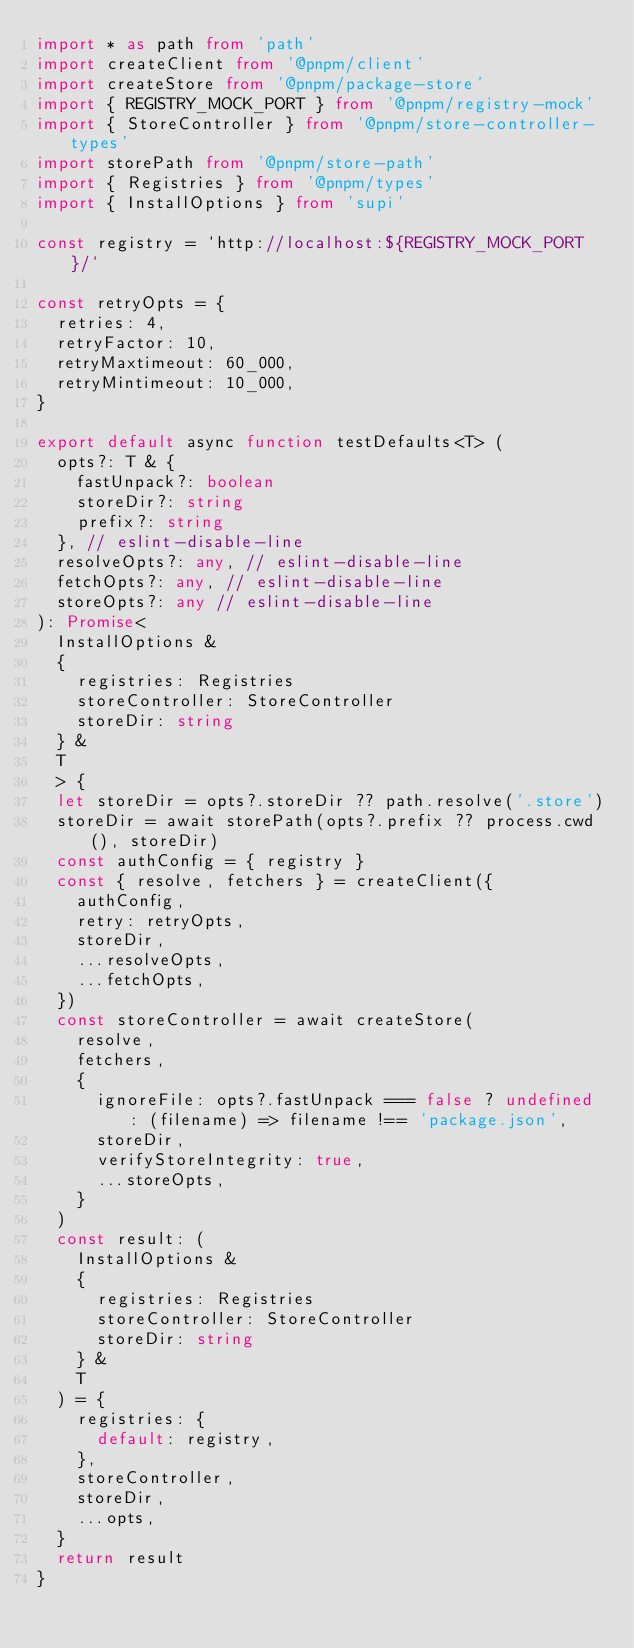<code> <loc_0><loc_0><loc_500><loc_500><_TypeScript_>import * as path from 'path'
import createClient from '@pnpm/client'
import createStore from '@pnpm/package-store'
import { REGISTRY_MOCK_PORT } from '@pnpm/registry-mock'
import { StoreController } from '@pnpm/store-controller-types'
import storePath from '@pnpm/store-path'
import { Registries } from '@pnpm/types'
import { InstallOptions } from 'supi'

const registry = `http://localhost:${REGISTRY_MOCK_PORT}/`

const retryOpts = {
  retries: 4,
  retryFactor: 10,
  retryMaxtimeout: 60_000,
  retryMintimeout: 10_000,
}

export default async function testDefaults<T> (
  opts?: T & {
    fastUnpack?: boolean
    storeDir?: string
    prefix?: string
  }, // eslint-disable-line
  resolveOpts?: any, // eslint-disable-line
  fetchOpts?: any, // eslint-disable-line
  storeOpts?: any // eslint-disable-line
): Promise<
  InstallOptions &
  {
    registries: Registries
    storeController: StoreController
    storeDir: string
  } &
  T
  > {
  let storeDir = opts?.storeDir ?? path.resolve('.store')
  storeDir = await storePath(opts?.prefix ?? process.cwd(), storeDir)
  const authConfig = { registry }
  const { resolve, fetchers } = createClient({
    authConfig,
    retry: retryOpts,
    storeDir,
    ...resolveOpts,
    ...fetchOpts,
  })
  const storeController = await createStore(
    resolve,
    fetchers,
    {
      ignoreFile: opts?.fastUnpack === false ? undefined : (filename) => filename !== 'package.json',
      storeDir,
      verifyStoreIntegrity: true,
      ...storeOpts,
    }
  )
  const result: (
    InstallOptions &
    {
      registries: Registries
      storeController: StoreController
      storeDir: string
    } &
    T
  ) = {
    registries: {
      default: registry,
    },
    storeController,
    storeDir,
    ...opts,
  }
  return result
}
</code> 